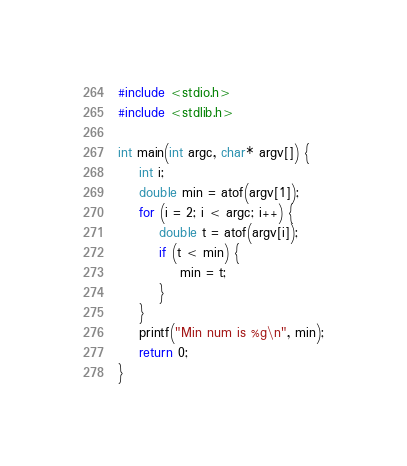<code> <loc_0><loc_0><loc_500><loc_500><_C_>#include <stdio.h>
#include <stdlib.h>

int main(int argc, char* argv[]) {
	int i;
	double min = atof(argv[1]);
	for (i = 2; i < argc; i++) {
		double t = atof(argv[i]);
		if (t < min) {
			min = t;
		}
	}
	printf("Min num is %g\n", min);
	return 0;
}
</code> 